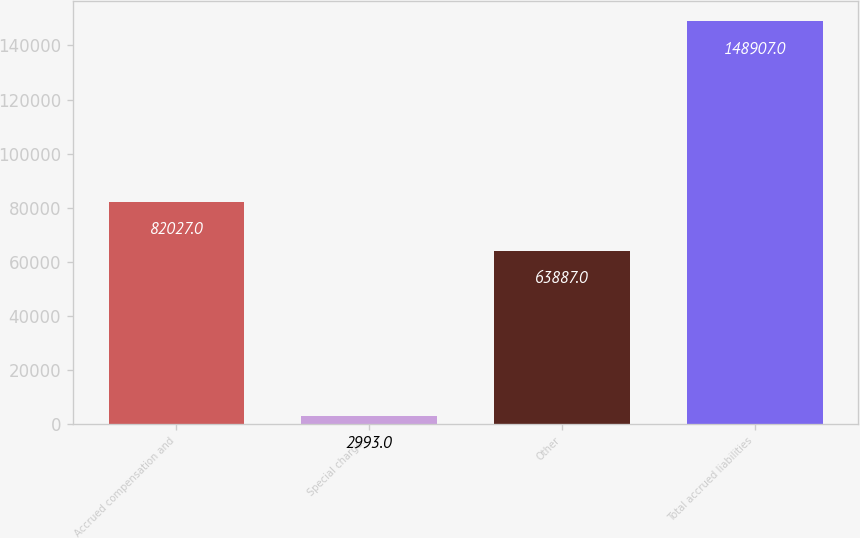<chart> <loc_0><loc_0><loc_500><loc_500><bar_chart><fcel>Accrued compensation and<fcel>Special charges<fcel>Other<fcel>Total accrued liabilities<nl><fcel>82027<fcel>2993<fcel>63887<fcel>148907<nl></chart> 